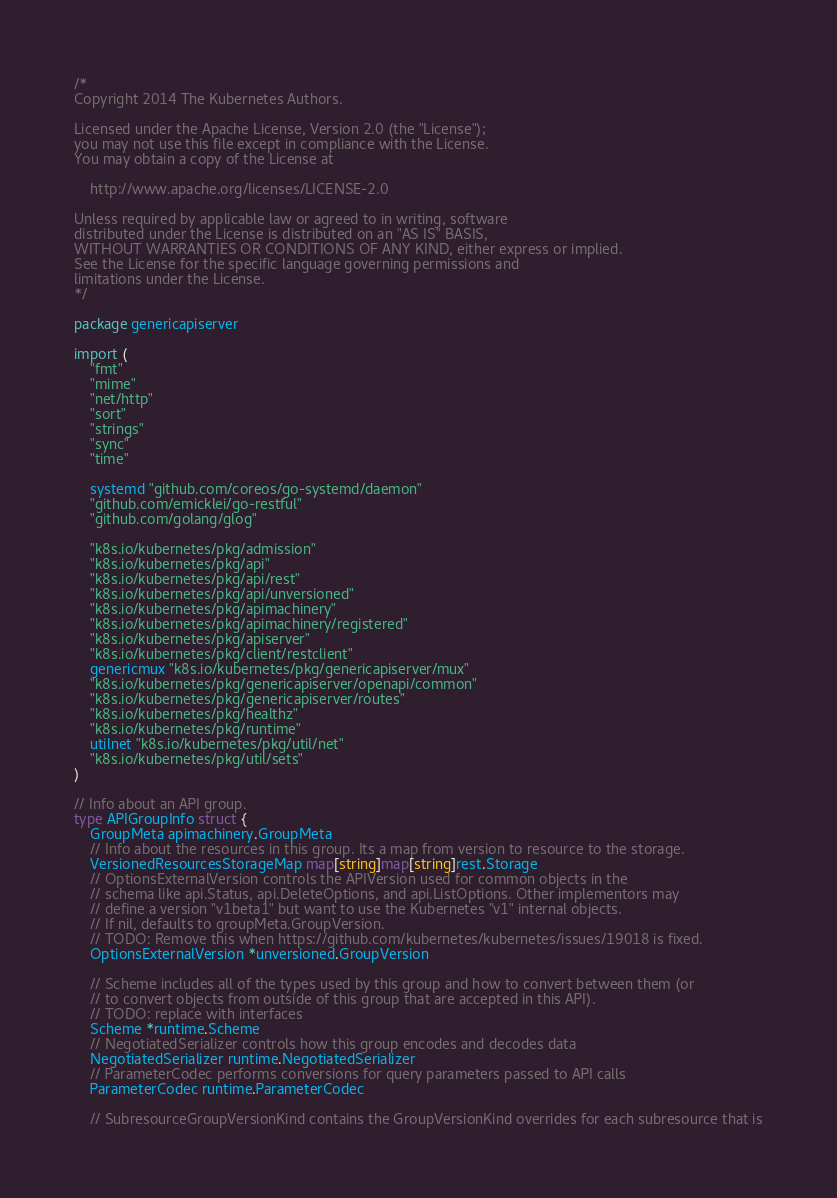Convert code to text. <code><loc_0><loc_0><loc_500><loc_500><_Go_>/*
Copyright 2014 The Kubernetes Authors.

Licensed under the Apache License, Version 2.0 (the "License");
you may not use this file except in compliance with the License.
You may obtain a copy of the License at

    http://www.apache.org/licenses/LICENSE-2.0

Unless required by applicable law or agreed to in writing, software
distributed under the License is distributed on an "AS IS" BASIS,
WITHOUT WARRANTIES OR CONDITIONS OF ANY KIND, either express or implied.
See the License for the specific language governing permissions and
limitations under the License.
*/

package genericapiserver

import (
	"fmt"
	"mime"
	"net/http"
	"sort"
	"strings"
	"sync"
	"time"

	systemd "github.com/coreos/go-systemd/daemon"
	"github.com/emicklei/go-restful"
	"github.com/golang/glog"

	"k8s.io/kubernetes/pkg/admission"
	"k8s.io/kubernetes/pkg/api"
	"k8s.io/kubernetes/pkg/api/rest"
	"k8s.io/kubernetes/pkg/api/unversioned"
	"k8s.io/kubernetes/pkg/apimachinery"
	"k8s.io/kubernetes/pkg/apimachinery/registered"
	"k8s.io/kubernetes/pkg/apiserver"
	"k8s.io/kubernetes/pkg/client/restclient"
	genericmux "k8s.io/kubernetes/pkg/genericapiserver/mux"
	"k8s.io/kubernetes/pkg/genericapiserver/openapi/common"
	"k8s.io/kubernetes/pkg/genericapiserver/routes"
	"k8s.io/kubernetes/pkg/healthz"
	"k8s.io/kubernetes/pkg/runtime"
	utilnet "k8s.io/kubernetes/pkg/util/net"
	"k8s.io/kubernetes/pkg/util/sets"
)

// Info about an API group.
type APIGroupInfo struct {
	GroupMeta apimachinery.GroupMeta
	// Info about the resources in this group. Its a map from version to resource to the storage.
	VersionedResourcesStorageMap map[string]map[string]rest.Storage
	// OptionsExternalVersion controls the APIVersion used for common objects in the
	// schema like api.Status, api.DeleteOptions, and api.ListOptions. Other implementors may
	// define a version "v1beta1" but want to use the Kubernetes "v1" internal objects.
	// If nil, defaults to groupMeta.GroupVersion.
	// TODO: Remove this when https://github.com/kubernetes/kubernetes/issues/19018 is fixed.
	OptionsExternalVersion *unversioned.GroupVersion

	// Scheme includes all of the types used by this group and how to convert between them (or
	// to convert objects from outside of this group that are accepted in this API).
	// TODO: replace with interfaces
	Scheme *runtime.Scheme
	// NegotiatedSerializer controls how this group encodes and decodes data
	NegotiatedSerializer runtime.NegotiatedSerializer
	// ParameterCodec performs conversions for query parameters passed to API calls
	ParameterCodec runtime.ParameterCodec

	// SubresourceGroupVersionKind contains the GroupVersionKind overrides for each subresource that is</code> 